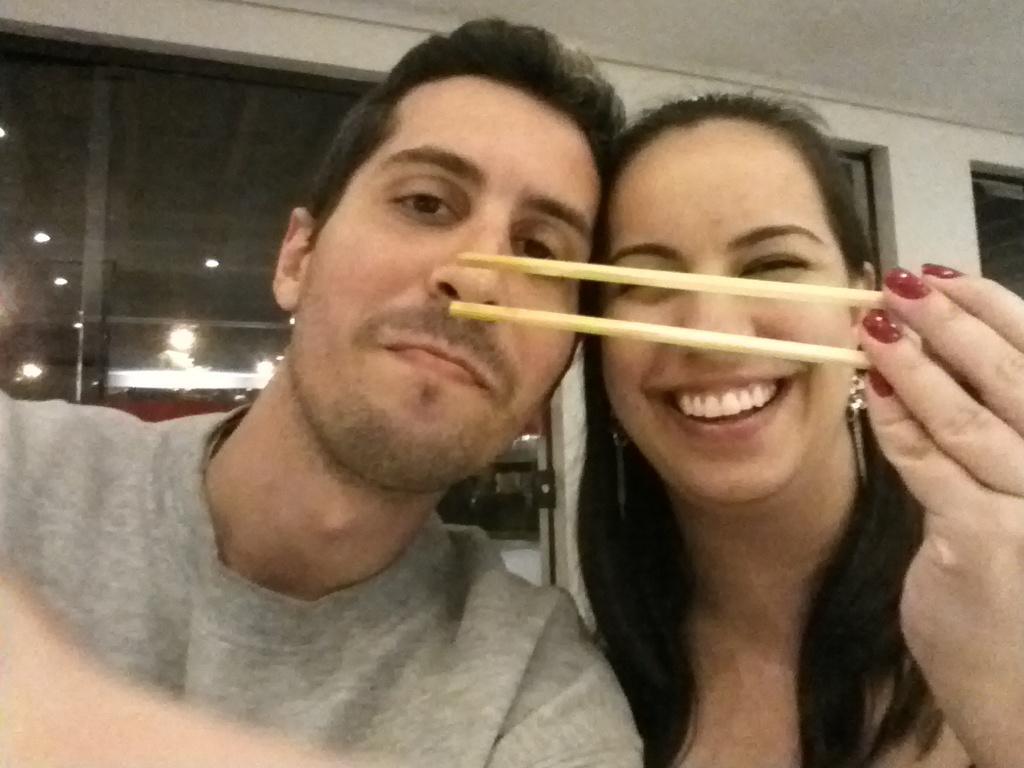Describe this image in one or two sentences. In this image, In the left side there is a man, In the right side there is a woman she is holding two sticks which are in yellow color, In the background there is a white color wall and there is a glass window. 